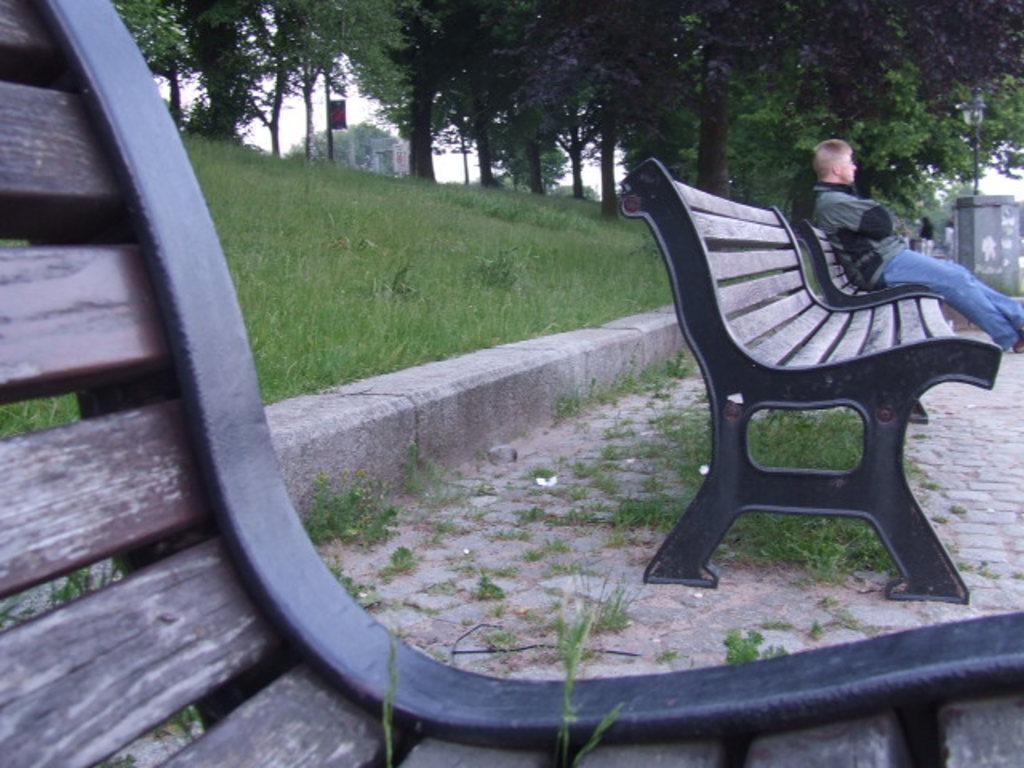Can you describe this image briefly? In this picture we can see a man who is sitting on the bench. This is grass. And there are many trees. Even we can see the sky here. 